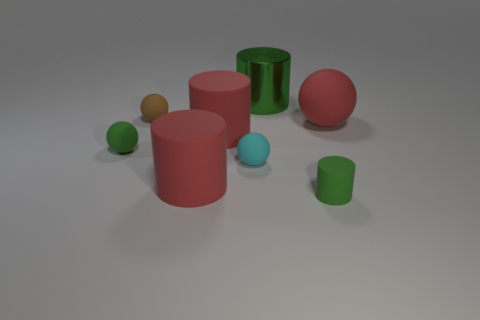Subtract all yellow cylinders. Subtract all purple balls. How many cylinders are left? 4 Add 2 small green metal objects. How many objects exist? 10 Add 6 tiny brown matte balls. How many tiny brown matte balls exist? 7 Subtract 1 cyan balls. How many objects are left? 7 Subtract all big matte things. Subtract all cyan matte balls. How many objects are left? 4 Add 6 small cylinders. How many small cylinders are left? 7 